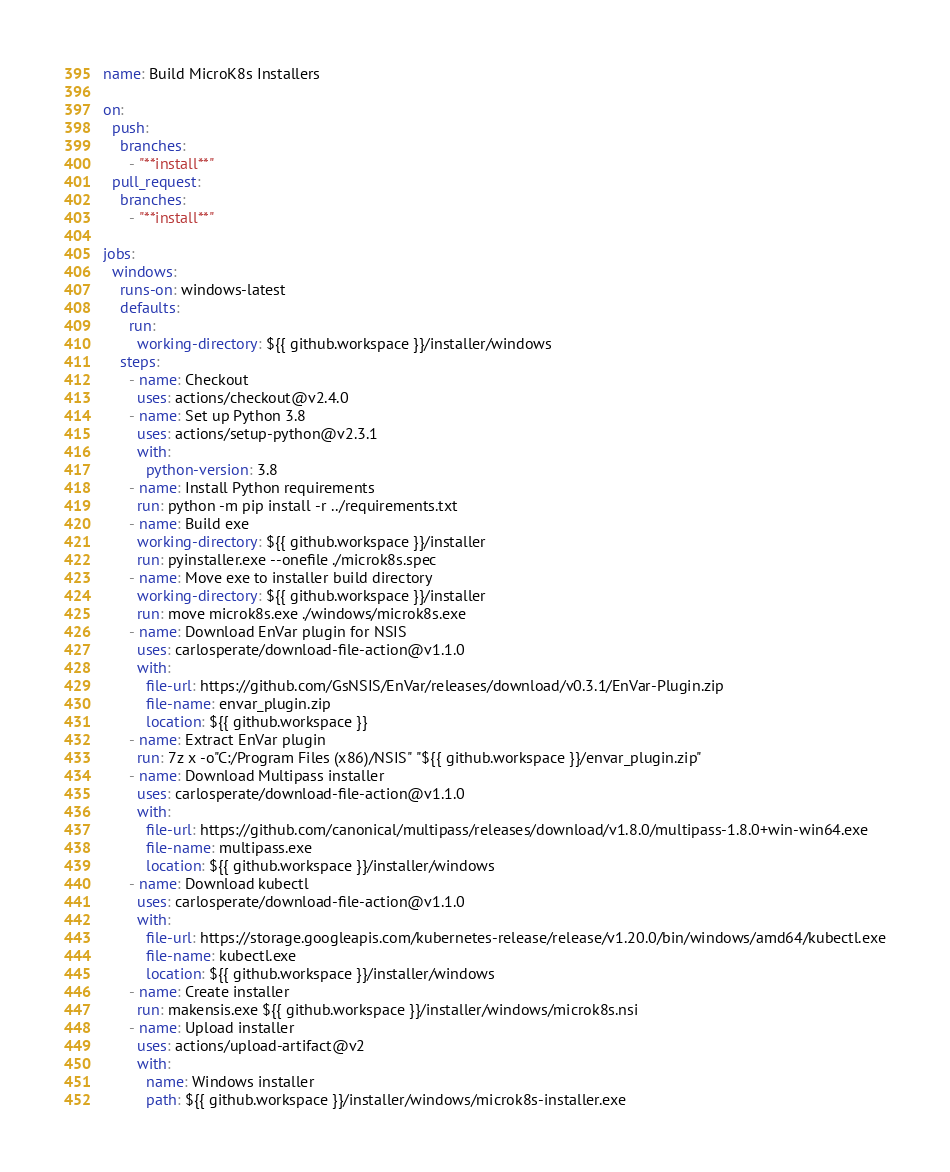Convert code to text. <code><loc_0><loc_0><loc_500><loc_500><_YAML_>name: Build MicroK8s Installers

on:
  push:
    branches:
      - "**install**"
  pull_request:
    branches:
      - "**install**"

jobs:
  windows:
    runs-on: windows-latest
    defaults:
      run:
        working-directory: ${{ github.workspace }}/installer/windows
    steps:
      - name: Checkout
        uses: actions/checkout@v2.4.0
      - name: Set up Python 3.8
        uses: actions/setup-python@v2.3.1
        with:
          python-version: 3.8
      - name: Install Python requirements
        run: python -m pip install -r ../requirements.txt
      - name: Build exe
        working-directory: ${{ github.workspace }}/installer
        run: pyinstaller.exe --onefile ./microk8s.spec
      - name: Move exe to installer build directory
        working-directory: ${{ github.workspace }}/installer
        run: move microk8s.exe ./windows/microk8s.exe
      - name: Download EnVar plugin for NSIS
        uses: carlosperate/download-file-action@v1.1.0
        with:
          file-url: https://github.com/GsNSIS/EnVar/releases/download/v0.3.1/EnVar-Plugin.zip
          file-name: envar_plugin.zip
          location: ${{ github.workspace }}
      - name: Extract EnVar plugin
        run: 7z x -o"C:/Program Files (x86)/NSIS" "${{ github.workspace }}/envar_plugin.zip"
      - name: Download Multipass installer
        uses: carlosperate/download-file-action@v1.1.0
        with:
          file-url: https://github.com/canonical/multipass/releases/download/v1.8.0/multipass-1.8.0+win-win64.exe
          file-name: multipass.exe
          location: ${{ github.workspace }}/installer/windows
      - name: Download kubectl
        uses: carlosperate/download-file-action@v1.1.0
        with:
          file-url: https://storage.googleapis.com/kubernetes-release/release/v1.20.0/bin/windows/amd64/kubectl.exe
          file-name: kubectl.exe
          location: ${{ github.workspace }}/installer/windows
      - name: Create installer
        run: makensis.exe ${{ github.workspace }}/installer/windows/microk8s.nsi
      - name: Upload installer
        uses: actions/upload-artifact@v2
        with:
          name: Windows installer
          path: ${{ github.workspace }}/installer/windows/microk8s-installer.exe
</code> 